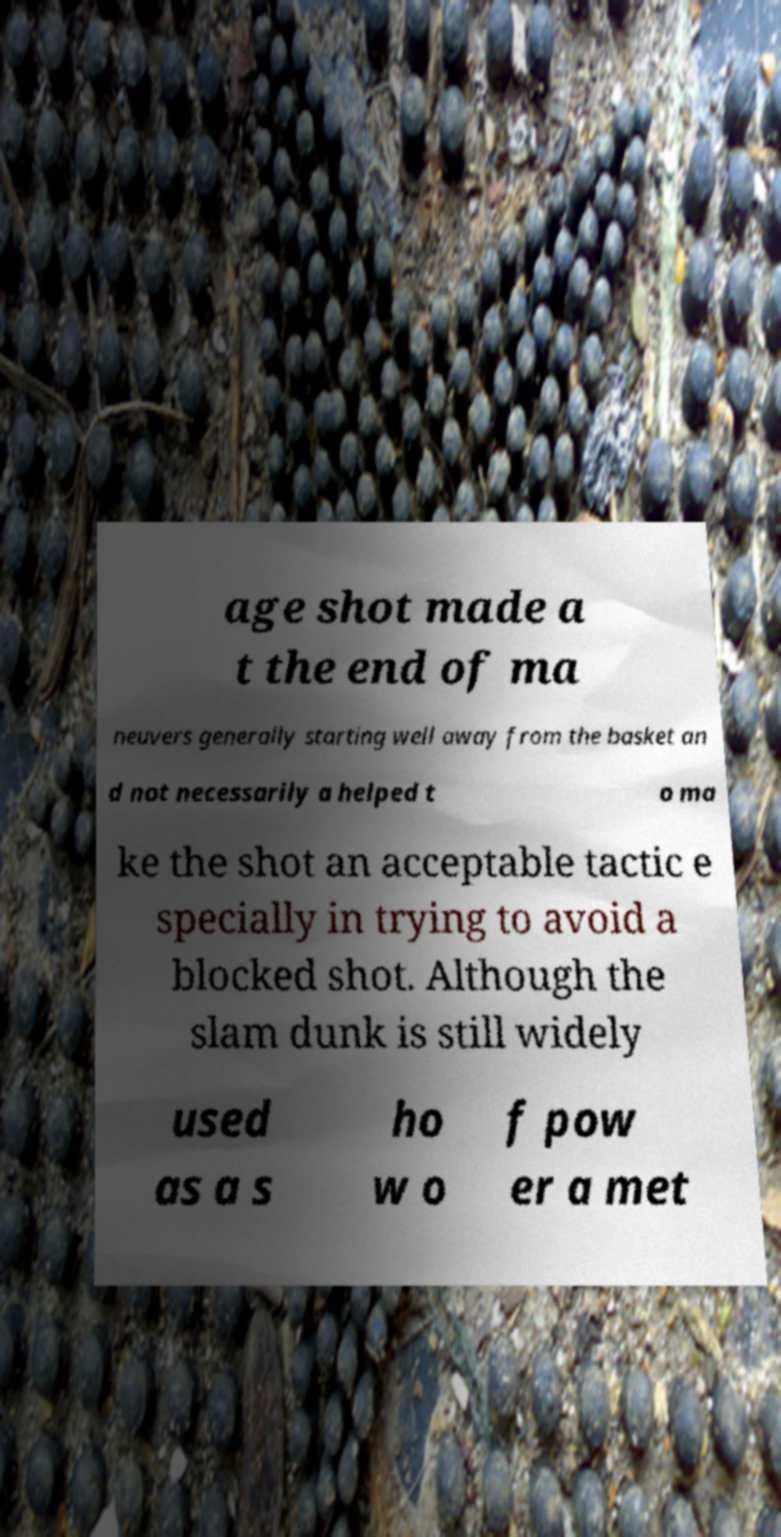Could you assist in decoding the text presented in this image and type it out clearly? age shot made a t the end of ma neuvers generally starting well away from the basket an d not necessarily a helped t o ma ke the shot an acceptable tactic e specially in trying to avoid a blocked shot. Although the slam dunk is still widely used as a s ho w o f pow er a met 